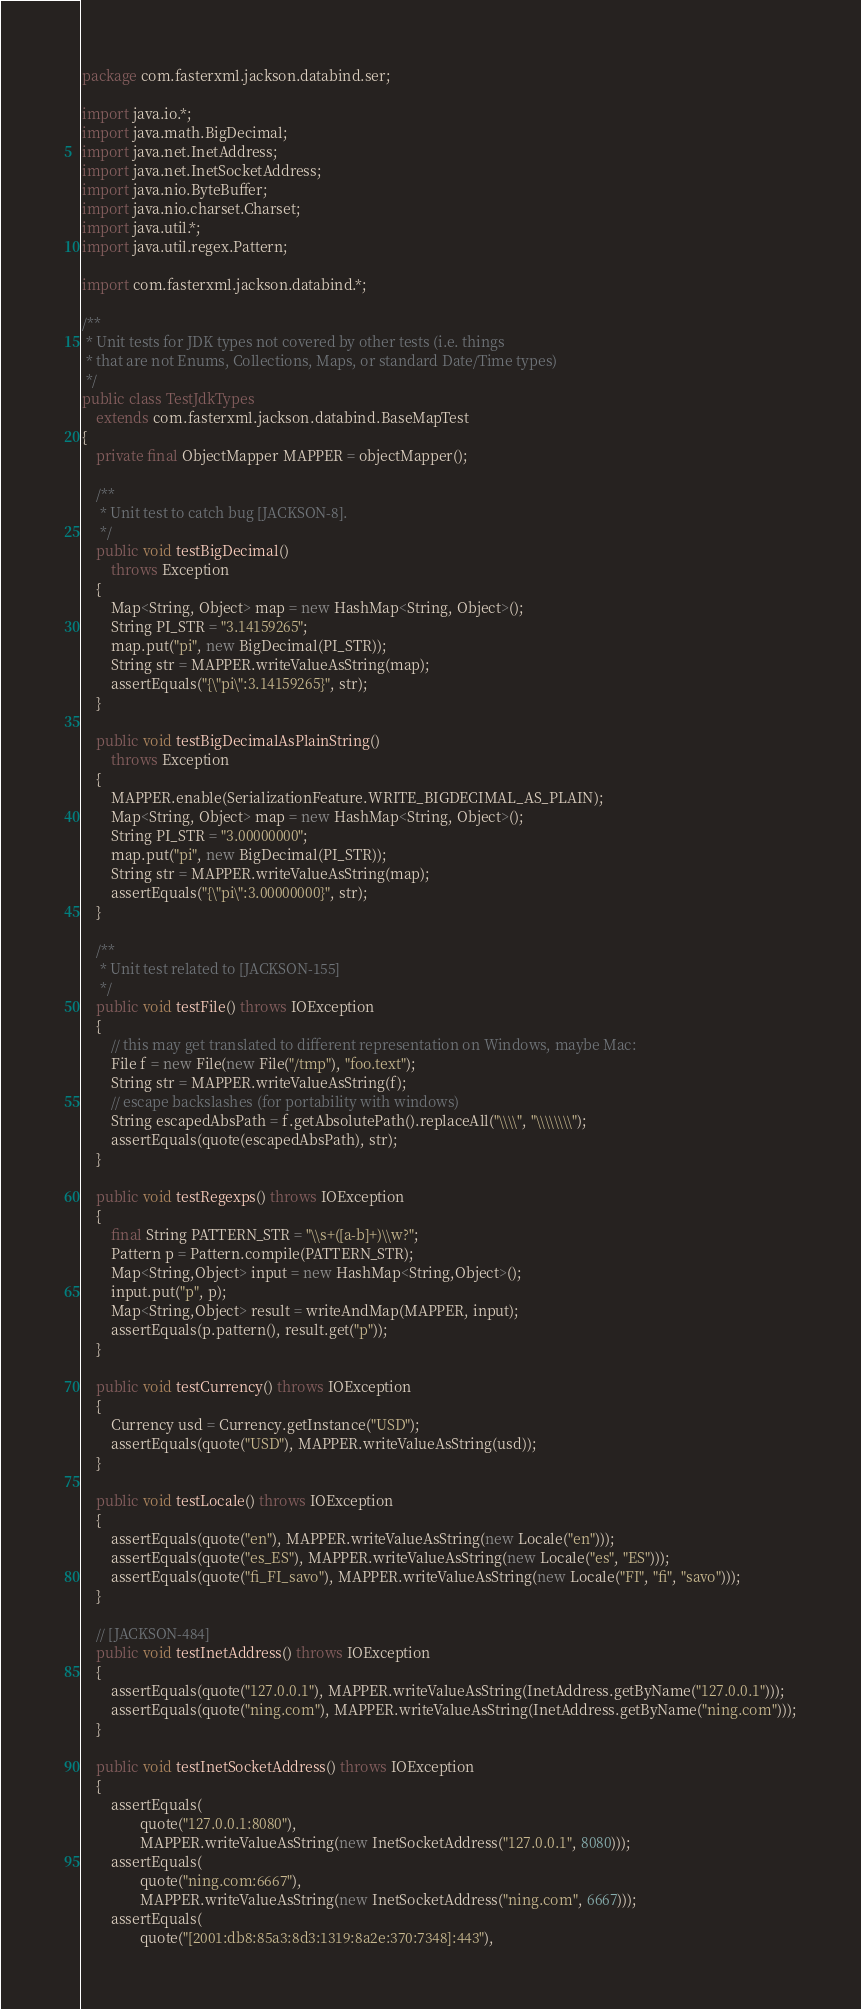<code> <loc_0><loc_0><loc_500><loc_500><_Java_>package com.fasterxml.jackson.databind.ser;

import java.io.*;
import java.math.BigDecimal;
import java.net.InetAddress;
import java.net.InetSocketAddress;
import java.nio.ByteBuffer;
import java.nio.charset.Charset;
import java.util.*;
import java.util.regex.Pattern;

import com.fasterxml.jackson.databind.*;

/**
 * Unit tests for JDK types not covered by other tests (i.e. things
 * that are not Enums, Collections, Maps, or standard Date/Time types)
 */
public class TestJdkTypes
    extends com.fasterxml.jackson.databind.BaseMapTest
{
    private final ObjectMapper MAPPER = objectMapper();
    
    /**
     * Unit test to catch bug [JACKSON-8].
     */
    public void testBigDecimal()
        throws Exception
    {
        Map<String, Object> map = new HashMap<String, Object>();
        String PI_STR = "3.14159265";
        map.put("pi", new BigDecimal(PI_STR));
        String str = MAPPER.writeValueAsString(map);
        assertEquals("{\"pi\":3.14159265}", str);
    }
    
    public void testBigDecimalAsPlainString()
        throws Exception
    {
        MAPPER.enable(SerializationFeature.WRITE_BIGDECIMAL_AS_PLAIN);
        Map<String, Object> map = new HashMap<String, Object>();
        String PI_STR = "3.00000000";
        map.put("pi", new BigDecimal(PI_STR));
        String str = MAPPER.writeValueAsString(map);
        assertEquals("{\"pi\":3.00000000}", str);
    }
    
    /**
     * Unit test related to [JACKSON-155]
     */
    public void testFile() throws IOException
    {
        // this may get translated to different representation on Windows, maybe Mac:
        File f = new File(new File("/tmp"), "foo.text");
        String str = MAPPER.writeValueAsString(f);
        // escape backslashes (for portability with windows)
        String escapedAbsPath = f.getAbsolutePath().replaceAll("\\\\", "\\\\\\\\"); 
        assertEquals(quote(escapedAbsPath), str);
    }

    public void testRegexps() throws IOException
    {
        final String PATTERN_STR = "\\s+([a-b]+)\\w?";
        Pattern p = Pattern.compile(PATTERN_STR);
        Map<String,Object> input = new HashMap<String,Object>();
        input.put("p", p);
        Map<String,Object> result = writeAndMap(MAPPER, input);
        assertEquals(p.pattern(), result.get("p"));
    }

    public void testCurrency() throws IOException
    {
        Currency usd = Currency.getInstance("USD");
        assertEquals(quote("USD"), MAPPER.writeValueAsString(usd));
    }

    public void testLocale() throws IOException
    {
        assertEquals(quote("en"), MAPPER.writeValueAsString(new Locale("en")));
        assertEquals(quote("es_ES"), MAPPER.writeValueAsString(new Locale("es", "ES")));
        assertEquals(quote("fi_FI_savo"), MAPPER.writeValueAsString(new Locale("FI", "fi", "savo")));
    }

    // [JACKSON-484]
    public void testInetAddress() throws IOException
    {
        assertEquals(quote("127.0.0.1"), MAPPER.writeValueAsString(InetAddress.getByName("127.0.0.1")));
        assertEquals(quote("ning.com"), MAPPER.writeValueAsString(InetAddress.getByName("ning.com")));
    }

    public void testInetSocketAddress() throws IOException
    {
        assertEquals(
                quote("127.0.0.1:8080"),
                MAPPER.writeValueAsString(new InetSocketAddress("127.0.0.1", 8080)));
        assertEquals(
                quote("ning.com:6667"),
                MAPPER.writeValueAsString(new InetSocketAddress("ning.com", 6667)));
        assertEquals(
                quote("[2001:db8:85a3:8d3:1319:8a2e:370:7348]:443"),</code> 